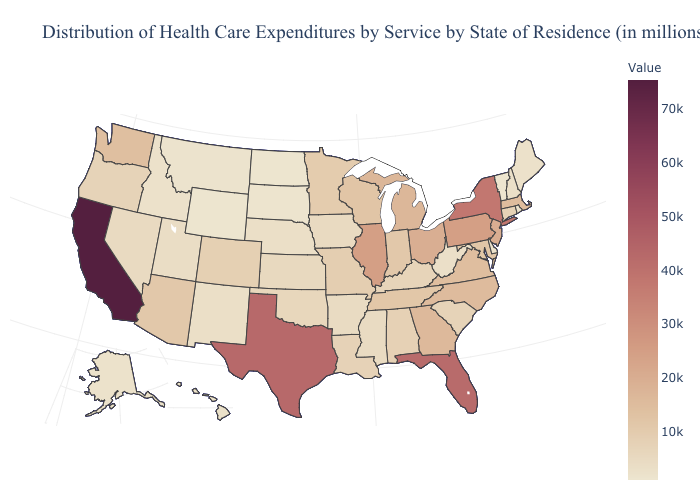Among the states that border Montana , does South Dakota have the highest value?
Be succinct. No. Does Arkansas have a higher value than Virginia?
Give a very brief answer. No. Which states have the lowest value in the USA?
Keep it brief. Wyoming. Which states have the lowest value in the USA?
Write a very short answer. Wyoming. Among the states that border Montana , which have the lowest value?
Answer briefly. Wyoming. Does California have the highest value in the USA?
Write a very short answer. Yes. Which states have the lowest value in the USA?
Write a very short answer. Wyoming. 